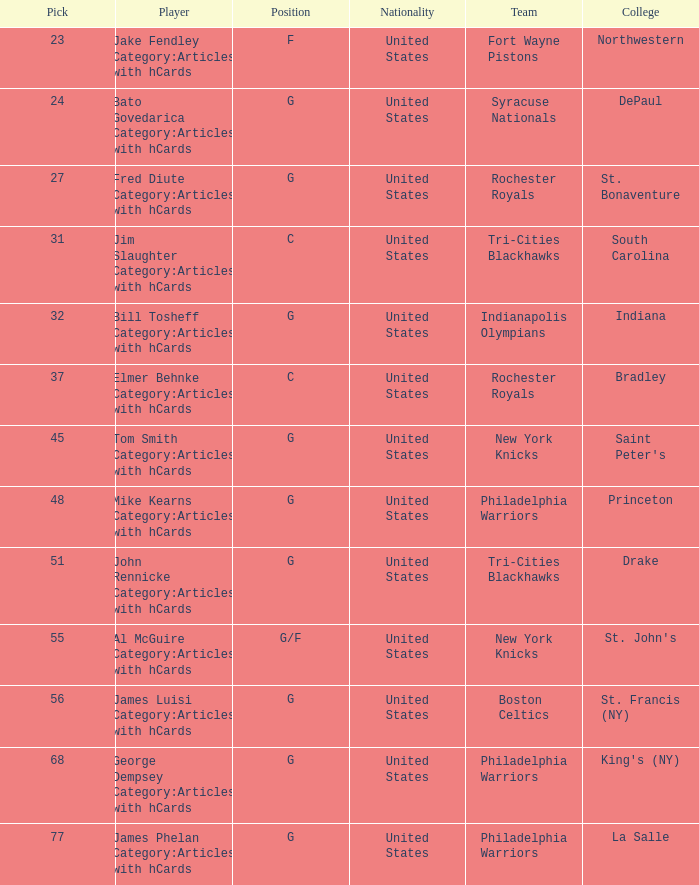What is the lowest pick number for players from king's (ny)? 68.0. 